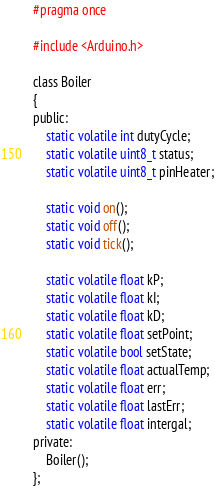Convert code to text. <code><loc_0><loc_0><loc_500><loc_500><_C_>#pragma once

#include <Arduino.h>

class Boiler
{
public:
    static volatile int dutyCycle;
    static volatile uint8_t status;
    static volatile uint8_t pinHeater;

    static void on();
    static void off();
    static void tick();

    static volatile float kP;
    static volatile float kI;
    static volatile float kD;
    static volatile float setPoint;
    static volatile bool setState;
    static volatile float actualTemp;
    static volatile float err;
    static volatile float lastErr;
    static volatile float intergal;
private:
    Boiler();
};</code> 